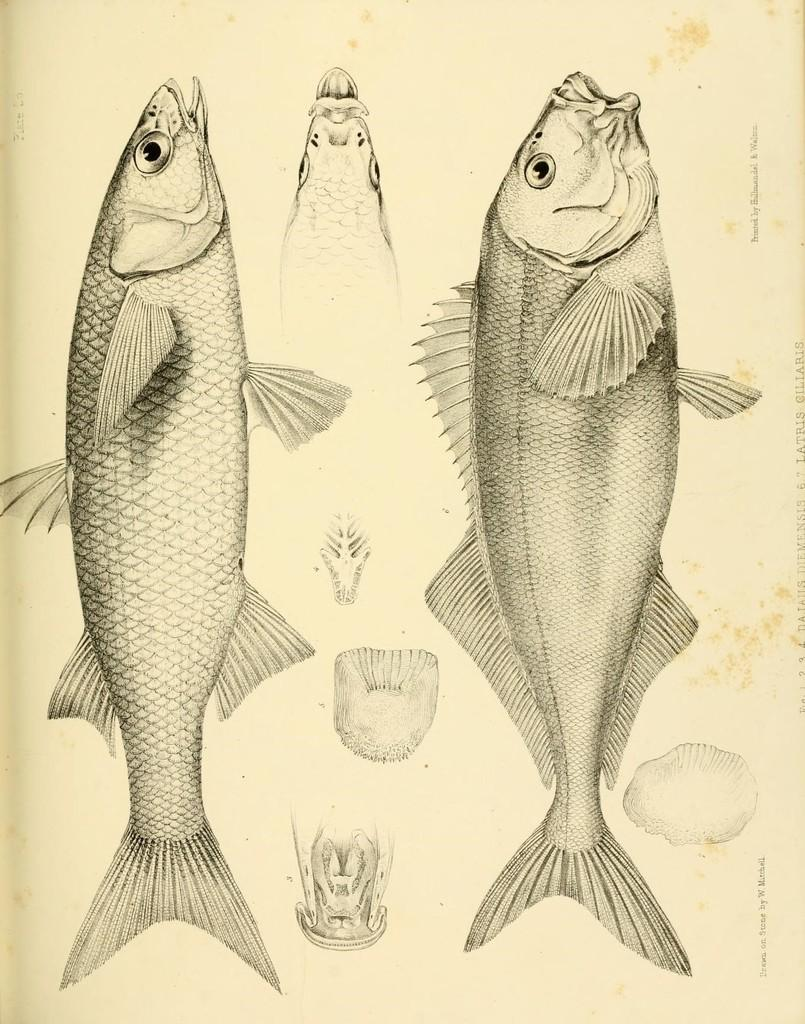What is depicted in the image? The image contains diagrams of two fishes. What information do the diagrams provide about the fishes? The diagrams show the parts of the fishes. How many kisses can be seen on the fishes in the image? There are no kisses depicted on the fishes in the image; it only shows diagrams of their parts. 